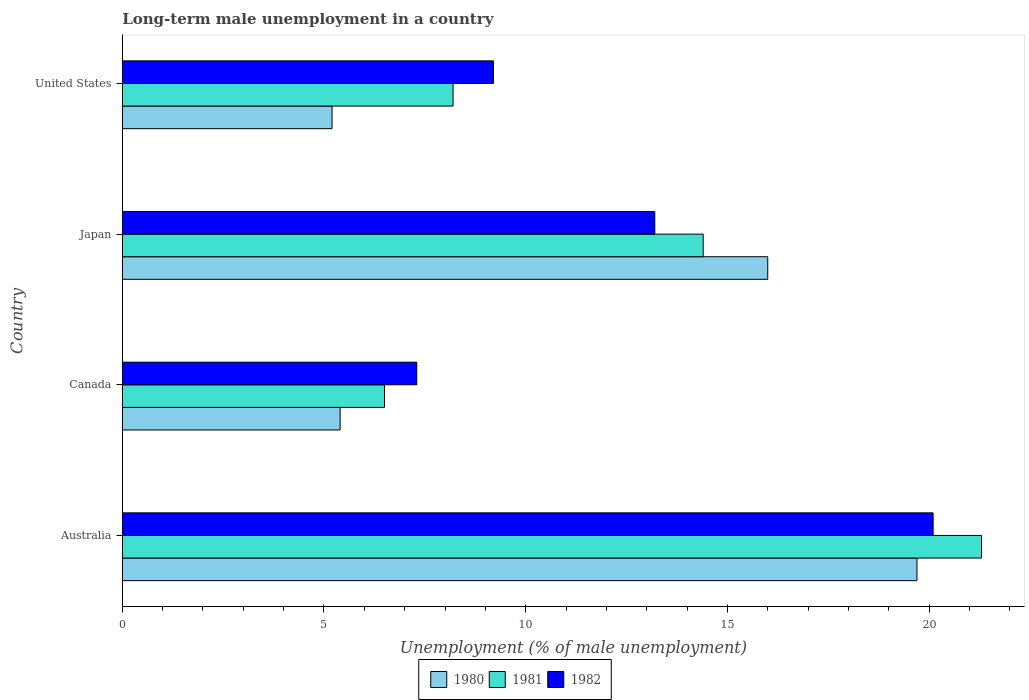How many different coloured bars are there?
Your response must be concise. 3. Are the number of bars per tick equal to the number of legend labels?
Ensure brevity in your answer.  Yes. How many bars are there on the 1st tick from the bottom?
Your answer should be very brief. 3. What is the percentage of long-term unemployed male population in 1980 in Australia?
Keep it short and to the point. 19.7. Across all countries, what is the maximum percentage of long-term unemployed male population in 1980?
Ensure brevity in your answer.  19.7. Across all countries, what is the minimum percentage of long-term unemployed male population in 1980?
Give a very brief answer. 5.2. In which country was the percentage of long-term unemployed male population in 1982 maximum?
Make the answer very short. Australia. What is the total percentage of long-term unemployed male population in 1980 in the graph?
Make the answer very short. 46.3. What is the difference between the percentage of long-term unemployed male population in 1981 in Canada and that in Japan?
Your answer should be very brief. -7.9. What is the difference between the percentage of long-term unemployed male population in 1981 in United States and the percentage of long-term unemployed male population in 1980 in Australia?
Give a very brief answer. -11.5. What is the average percentage of long-term unemployed male population in 1981 per country?
Ensure brevity in your answer.  12.6. What is the difference between the percentage of long-term unemployed male population in 1982 and percentage of long-term unemployed male population in 1980 in Canada?
Your response must be concise. 1.9. What is the ratio of the percentage of long-term unemployed male population in 1980 in Canada to that in United States?
Keep it short and to the point. 1.04. Is the difference between the percentage of long-term unemployed male population in 1982 in Canada and United States greater than the difference between the percentage of long-term unemployed male population in 1980 in Canada and United States?
Make the answer very short. No. What is the difference between the highest and the second highest percentage of long-term unemployed male population in 1980?
Your response must be concise. 3.7. What is the difference between the highest and the lowest percentage of long-term unemployed male population in 1980?
Your response must be concise. 14.5. In how many countries, is the percentage of long-term unemployed male population in 1981 greater than the average percentage of long-term unemployed male population in 1981 taken over all countries?
Make the answer very short. 2. What does the 3rd bar from the top in Canada represents?
Keep it short and to the point. 1980. Is it the case that in every country, the sum of the percentage of long-term unemployed male population in 1980 and percentage of long-term unemployed male population in 1982 is greater than the percentage of long-term unemployed male population in 1981?
Offer a terse response. Yes. How many bars are there?
Keep it short and to the point. 12. What is the difference between two consecutive major ticks on the X-axis?
Offer a very short reply. 5. Does the graph contain any zero values?
Provide a short and direct response. No. What is the title of the graph?
Make the answer very short. Long-term male unemployment in a country. What is the label or title of the X-axis?
Ensure brevity in your answer.  Unemployment (% of male unemployment). What is the Unemployment (% of male unemployment) in 1980 in Australia?
Your answer should be compact. 19.7. What is the Unemployment (% of male unemployment) in 1981 in Australia?
Make the answer very short. 21.3. What is the Unemployment (% of male unemployment) in 1982 in Australia?
Ensure brevity in your answer.  20.1. What is the Unemployment (% of male unemployment) of 1980 in Canada?
Your answer should be compact. 5.4. What is the Unemployment (% of male unemployment) in 1981 in Canada?
Ensure brevity in your answer.  6.5. What is the Unemployment (% of male unemployment) of 1982 in Canada?
Your answer should be very brief. 7.3. What is the Unemployment (% of male unemployment) of 1981 in Japan?
Your answer should be compact. 14.4. What is the Unemployment (% of male unemployment) in 1982 in Japan?
Provide a short and direct response. 13.2. What is the Unemployment (% of male unemployment) in 1980 in United States?
Offer a terse response. 5.2. What is the Unemployment (% of male unemployment) of 1981 in United States?
Ensure brevity in your answer.  8.2. What is the Unemployment (% of male unemployment) in 1982 in United States?
Provide a short and direct response. 9.2. Across all countries, what is the maximum Unemployment (% of male unemployment) in 1980?
Your answer should be very brief. 19.7. Across all countries, what is the maximum Unemployment (% of male unemployment) in 1981?
Offer a terse response. 21.3. Across all countries, what is the maximum Unemployment (% of male unemployment) in 1982?
Your response must be concise. 20.1. Across all countries, what is the minimum Unemployment (% of male unemployment) in 1980?
Provide a succinct answer. 5.2. Across all countries, what is the minimum Unemployment (% of male unemployment) in 1982?
Your answer should be very brief. 7.3. What is the total Unemployment (% of male unemployment) of 1980 in the graph?
Offer a very short reply. 46.3. What is the total Unemployment (% of male unemployment) of 1981 in the graph?
Your response must be concise. 50.4. What is the total Unemployment (% of male unemployment) of 1982 in the graph?
Provide a short and direct response. 49.8. What is the difference between the Unemployment (% of male unemployment) in 1980 in Australia and that in Canada?
Provide a short and direct response. 14.3. What is the difference between the Unemployment (% of male unemployment) of 1981 in Australia and that in Canada?
Make the answer very short. 14.8. What is the difference between the Unemployment (% of male unemployment) in 1980 in Australia and that in Japan?
Make the answer very short. 3.7. What is the difference between the Unemployment (% of male unemployment) of 1981 in Australia and that in Japan?
Your answer should be compact. 6.9. What is the difference between the Unemployment (% of male unemployment) in 1982 in Australia and that in Japan?
Keep it short and to the point. 6.9. What is the difference between the Unemployment (% of male unemployment) of 1980 in Australia and that in United States?
Ensure brevity in your answer.  14.5. What is the difference between the Unemployment (% of male unemployment) in 1982 in Australia and that in United States?
Provide a succinct answer. 10.9. What is the difference between the Unemployment (% of male unemployment) in 1982 in Canada and that in United States?
Your answer should be compact. -1.9. What is the difference between the Unemployment (% of male unemployment) in 1982 in Japan and that in United States?
Offer a terse response. 4. What is the difference between the Unemployment (% of male unemployment) of 1980 in Australia and the Unemployment (% of male unemployment) of 1981 in Canada?
Your answer should be very brief. 13.2. What is the difference between the Unemployment (% of male unemployment) of 1980 in Australia and the Unemployment (% of male unemployment) of 1981 in United States?
Offer a terse response. 11.5. What is the difference between the Unemployment (% of male unemployment) in 1980 in Canada and the Unemployment (% of male unemployment) in 1981 in United States?
Your answer should be very brief. -2.8. What is the difference between the Unemployment (% of male unemployment) of 1980 in Japan and the Unemployment (% of male unemployment) of 1981 in United States?
Provide a short and direct response. 7.8. What is the difference between the Unemployment (% of male unemployment) in 1981 in Japan and the Unemployment (% of male unemployment) in 1982 in United States?
Keep it short and to the point. 5.2. What is the average Unemployment (% of male unemployment) of 1980 per country?
Provide a succinct answer. 11.57. What is the average Unemployment (% of male unemployment) in 1982 per country?
Provide a short and direct response. 12.45. What is the difference between the Unemployment (% of male unemployment) in 1981 and Unemployment (% of male unemployment) in 1982 in Australia?
Keep it short and to the point. 1.2. What is the difference between the Unemployment (% of male unemployment) of 1980 and Unemployment (% of male unemployment) of 1981 in Canada?
Keep it short and to the point. -1.1. What is the difference between the Unemployment (% of male unemployment) in 1980 and Unemployment (% of male unemployment) in 1982 in Canada?
Your response must be concise. -1.9. What is the difference between the Unemployment (% of male unemployment) in 1981 and Unemployment (% of male unemployment) in 1982 in Canada?
Ensure brevity in your answer.  -0.8. What is the difference between the Unemployment (% of male unemployment) of 1980 and Unemployment (% of male unemployment) of 1981 in Japan?
Offer a terse response. 1.6. What is the difference between the Unemployment (% of male unemployment) of 1981 and Unemployment (% of male unemployment) of 1982 in Japan?
Your answer should be very brief. 1.2. What is the ratio of the Unemployment (% of male unemployment) of 1980 in Australia to that in Canada?
Provide a short and direct response. 3.65. What is the ratio of the Unemployment (% of male unemployment) in 1981 in Australia to that in Canada?
Ensure brevity in your answer.  3.28. What is the ratio of the Unemployment (% of male unemployment) in 1982 in Australia to that in Canada?
Keep it short and to the point. 2.75. What is the ratio of the Unemployment (% of male unemployment) in 1980 in Australia to that in Japan?
Provide a succinct answer. 1.23. What is the ratio of the Unemployment (% of male unemployment) in 1981 in Australia to that in Japan?
Give a very brief answer. 1.48. What is the ratio of the Unemployment (% of male unemployment) of 1982 in Australia to that in Japan?
Offer a terse response. 1.52. What is the ratio of the Unemployment (% of male unemployment) in 1980 in Australia to that in United States?
Provide a short and direct response. 3.79. What is the ratio of the Unemployment (% of male unemployment) in 1981 in Australia to that in United States?
Provide a short and direct response. 2.6. What is the ratio of the Unemployment (% of male unemployment) of 1982 in Australia to that in United States?
Offer a very short reply. 2.18. What is the ratio of the Unemployment (% of male unemployment) of 1980 in Canada to that in Japan?
Your response must be concise. 0.34. What is the ratio of the Unemployment (% of male unemployment) in 1981 in Canada to that in Japan?
Your answer should be very brief. 0.45. What is the ratio of the Unemployment (% of male unemployment) in 1982 in Canada to that in Japan?
Give a very brief answer. 0.55. What is the ratio of the Unemployment (% of male unemployment) in 1981 in Canada to that in United States?
Ensure brevity in your answer.  0.79. What is the ratio of the Unemployment (% of male unemployment) of 1982 in Canada to that in United States?
Ensure brevity in your answer.  0.79. What is the ratio of the Unemployment (% of male unemployment) of 1980 in Japan to that in United States?
Offer a terse response. 3.08. What is the ratio of the Unemployment (% of male unemployment) of 1981 in Japan to that in United States?
Offer a very short reply. 1.76. What is the ratio of the Unemployment (% of male unemployment) in 1982 in Japan to that in United States?
Keep it short and to the point. 1.43. What is the difference between the highest and the second highest Unemployment (% of male unemployment) in 1982?
Offer a terse response. 6.9. What is the difference between the highest and the lowest Unemployment (% of male unemployment) in 1980?
Provide a succinct answer. 14.5. 